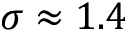<formula> <loc_0><loc_0><loc_500><loc_500>\sigma \approx 1 . 4</formula> 